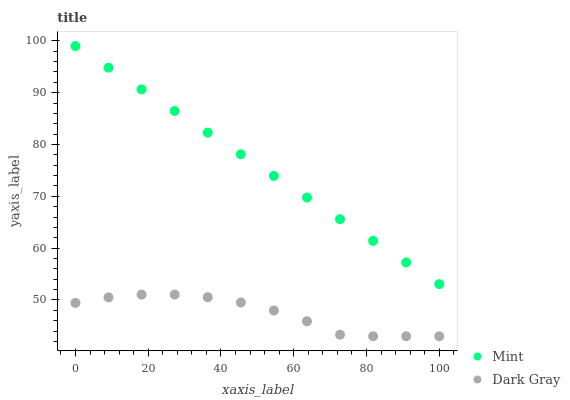Does Dark Gray have the minimum area under the curve?
Answer yes or no. Yes. Does Mint have the maximum area under the curve?
Answer yes or no. Yes. Does Mint have the minimum area under the curve?
Answer yes or no. No. Is Mint the smoothest?
Answer yes or no. Yes. Is Dark Gray the roughest?
Answer yes or no. Yes. Is Mint the roughest?
Answer yes or no. No. Does Dark Gray have the lowest value?
Answer yes or no. Yes. Does Mint have the lowest value?
Answer yes or no. No. Does Mint have the highest value?
Answer yes or no. Yes. Is Dark Gray less than Mint?
Answer yes or no. Yes. Is Mint greater than Dark Gray?
Answer yes or no. Yes. Does Dark Gray intersect Mint?
Answer yes or no. No. 